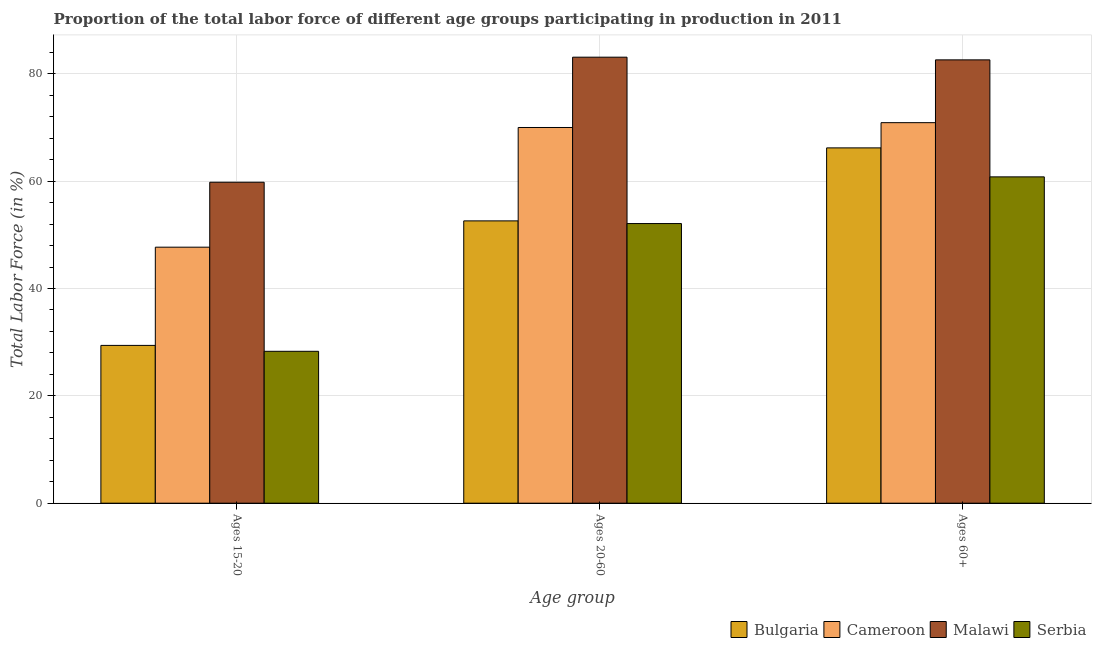How many groups of bars are there?
Give a very brief answer. 3. Are the number of bars on each tick of the X-axis equal?
Give a very brief answer. Yes. How many bars are there on the 2nd tick from the left?
Give a very brief answer. 4. What is the label of the 1st group of bars from the left?
Keep it short and to the point. Ages 15-20. What is the percentage of labor force within the age group 20-60 in Cameroon?
Offer a terse response. 70. Across all countries, what is the maximum percentage of labor force within the age group 20-60?
Your answer should be very brief. 83.1. Across all countries, what is the minimum percentage of labor force above age 60?
Offer a terse response. 60.8. In which country was the percentage of labor force within the age group 20-60 maximum?
Make the answer very short. Malawi. In which country was the percentage of labor force within the age group 15-20 minimum?
Ensure brevity in your answer.  Serbia. What is the total percentage of labor force within the age group 20-60 in the graph?
Offer a terse response. 257.8. What is the difference between the percentage of labor force within the age group 20-60 in Serbia and that in Cameroon?
Your response must be concise. -17.9. What is the difference between the percentage of labor force within the age group 20-60 in Serbia and the percentage of labor force above age 60 in Bulgaria?
Offer a very short reply. -14.1. What is the average percentage of labor force above age 60 per country?
Your response must be concise. 70.12. What is the difference between the percentage of labor force within the age group 15-20 and percentage of labor force within the age group 20-60 in Malawi?
Your response must be concise. -23.3. In how many countries, is the percentage of labor force within the age group 20-60 greater than 16 %?
Your answer should be very brief. 4. What is the ratio of the percentage of labor force within the age group 20-60 in Bulgaria to that in Malawi?
Ensure brevity in your answer.  0.63. Is the percentage of labor force within the age group 15-20 in Malawi less than that in Cameroon?
Offer a very short reply. No. Is the difference between the percentage of labor force within the age group 20-60 in Malawi and Bulgaria greater than the difference between the percentage of labor force within the age group 15-20 in Malawi and Bulgaria?
Your answer should be compact. Yes. What is the difference between the highest and the second highest percentage of labor force within the age group 15-20?
Your answer should be compact. 12.1. What is the difference between the highest and the lowest percentage of labor force above age 60?
Ensure brevity in your answer.  21.8. What does the 3rd bar from the left in Ages 60+ represents?
Your answer should be very brief. Malawi. What does the 2nd bar from the right in Ages 60+ represents?
Offer a very short reply. Malawi. Is it the case that in every country, the sum of the percentage of labor force within the age group 15-20 and percentage of labor force within the age group 20-60 is greater than the percentage of labor force above age 60?
Keep it short and to the point. Yes. What is the difference between two consecutive major ticks on the Y-axis?
Ensure brevity in your answer.  20. Where does the legend appear in the graph?
Offer a terse response. Bottom right. How many legend labels are there?
Your answer should be compact. 4. What is the title of the graph?
Provide a short and direct response. Proportion of the total labor force of different age groups participating in production in 2011. What is the label or title of the X-axis?
Your response must be concise. Age group. What is the Total Labor Force (in %) of Bulgaria in Ages 15-20?
Provide a succinct answer. 29.4. What is the Total Labor Force (in %) of Cameroon in Ages 15-20?
Keep it short and to the point. 47.7. What is the Total Labor Force (in %) in Malawi in Ages 15-20?
Give a very brief answer. 59.8. What is the Total Labor Force (in %) in Serbia in Ages 15-20?
Make the answer very short. 28.3. What is the Total Labor Force (in %) of Bulgaria in Ages 20-60?
Offer a very short reply. 52.6. What is the Total Labor Force (in %) of Malawi in Ages 20-60?
Your answer should be compact. 83.1. What is the Total Labor Force (in %) in Serbia in Ages 20-60?
Your answer should be compact. 52.1. What is the Total Labor Force (in %) of Bulgaria in Ages 60+?
Your response must be concise. 66.2. What is the Total Labor Force (in %) in Cameroon in Ages 60+?
Provide a short and direct response. 70.9. What is the Total Labor Force (in %) of Malawi in Ages 60+?
Ensure brevity in your answer.  82.6. What is the Total Labor Force (in %) in Serbia in Ages 60+?
Provide a short and direct response. 60.8. Across all Age group, what is the maximum Total Labor Force (in %) in Bulgaria?
Keep it short and to the point. 66.2. Across all Age group, what is the maximum Total Labor Force (in %) of Cameroon?
Your answer should be compact. 70.9. Across all Age group, what is the maximum Total Labor Force (in %) of Malawi?
Your answer should be very brief. 83.1. Across all Age group, what is the maximum Total Labor Force (in %) of Serbia?
Offer a terse response. 60.8. Across all Age group, what is the minimum Total Labor Force (in %) in Bulgaria?
Provide a short and direct response. 29.4. Across all Age group, what is the minimum Total Labor Force (in %) in Cameroon?
Ensure brevity in your answer.  47.7. Across all Age group, what is the minimum Total Labor Force (in %) of Malawi?
Offer a very short reply. 59.8. Across all Age group, what is the minimum Total Labor Force (in %) of Serbia?
Your response must be concise. 28.3. What is the total Total Labor Force (in %) in Bulgaria in the graph?
Offer a terse response. 148.2. What is the total Total Labor Force (in %) in Cameroon in the graph?
Ensure brevity in your answer.  188.6. What is the total Total Labor Force (in %) of Malawi in the graph?
Offer a very short reply. 225.5. What is the total Total Labor Force (in %) in Serbia in the graph?
Your answer should be compact. 141.2. What is the difference between the Total Labor Force (in %) in Bulgaria in Ages 15-20 and that in Ages 20-60?
Ensure brevity in your answer.  -23.2. What is the difference between the Total Labor Force (in %) in Cameroon in Ages 15-20 and that in Ages 20-60?
Ensure brevity in your answer.  -22.3. What is the difference between the Total Labor Force (in %) of Malawi in Ages 15-20 and that in Ages 20-60?
Your answer should be compact. -23.3. What is the difference between the Total Labor Force (in %) of Serbia in Ages 15-20 and that in Ages 20-60?
Make the answer very short. -23.8. What is the difference between the Total Labor Force (in %) of Bulgaria in Ages 15-20 and that in Ages 60+?
Provide a short and direct response. -36.8. What is the difference between the Total Labor Force (in %) of Cameroon in Ages 15-20 and that in Ages 60+?
Your answer should be very brief. -23.2. What is the difference between the Total Labor Force (in %) of Malawi in Ages 15-20 and that in Ages 60+?
Give a very brief answer. -22.8. What is the difference between the Total Labor Force (in %) of Serbia in Ages 15-20 and that in Ages 60+?
Ensure brevity in your answer.  -32.5. What is the difference between the Total Labor Force (in %) in Cameroon in Ages 20-60 and that in Ages 60+?
Offer a very short reply. -0.9. What is the difference between the Total Labor Force (in %) in Malawi in Ages 20-60 and that in Ages 60+?
Your answer should be very brief. 0.5. What is the difference between the Total Labor Force (in %) of Bulgaria in Ages 15-20 and the Total Labor Force (in %) of Cameroon in Ages 20-60?
Your answer should be compact. -40.6. What is the difference between the Total Labor Force (in %) of Bulgaria in Ages 15-20 and the Total Labor Force (in %) of Malawi in Ages 20-60?
Your answer should be very brief. -53.7. What is the difference between the Total Labor Force (in %) in Bulgaria in Ages 15-20 and the Total Labor Force (in %) in Serbia in Ages 20-60?
Give a very brief answer. -22.7. What is the difference between the Total Labor Force (in %) of Cameroon in Ages 15-20 and the Total Labor Force (in %) of Malawi in Ages 20-60?
Provide a succinct answer. -35.4. What is the difference between the Total Labor Force (in %) in Malawi in Ages 15-20 and the Total Labor Force (in %) in Serbia in Ages 20-60?
Ensure brevity in your answer.  7.7. What is the difference between the Total Labor Force (in %) in Bulgaria in Ages 15-20 and the Total Labor Force (in %) in Cameroon in Ages 60+?
Give a very brief answer. -41.5. What is the difference between the Total Labor Force (in %) of Bulgaria in Ages 15-20 and the Total Labor Force (in %) of Malawi in Ages 60+?
Offer a very short reply. -53.2. What is the difference between the Total Labor Force (in %) in Bulgaria in Ages 15-20 and the Total Labor Force (in %) in Serbia in Ages 60+?
Your answer should be compact. -31.4. What is the difference between the Total Labor Force (in %) in Cameroon in Ages 15-20 and the Total Labor Force (in %) in Malawi in Ages 60+?
Provide a succinct answer. -34.9. What is the difference between the Total Labor Force (in %) in Bulgaria in Ages 20-60 and the Total Labor Force (in %) in Cameroon in Ages 60+?
Provide a succinct answer. -18.3. What is the difference between the Total Labor Force (in %) in Bulgaria in Ages 20-60 and the Total Labor Force (in %) in Malawi in Ages 60+?
Your answer should be very brief. -30. What is the difference between the Total Labor Force (in %) in Cameroon in Ages 20-60 and the Total Labor Force (in %) in Serbia in Ages 60+?
Your answer should be very brief. 9.2. What is the difference between the Total Labor Force (in %) of Malawi in Ages 20-60 and the Total Labor Force (in %) of Serbia in Ages 60+?
Make the answer very short. 22.3. What is the average Total Labor Force (in %) in Bulgaria per Age group?
Provide a succinct answer. 49.4. What is the average Total Labor Force (in %) of Cameroon per Age group?
Make the answer very short. 62.87. What is the average Total Labor Force (in %) of Malawi per Age group?
Make the answer very short. 75.17. What is the average Total Labor Force (in %) in Serbia per Age group?
Ensure brevity in your answer.  47.07. What is the difference between the Total Labor Force (in %) in Bulgaria and Total Labor Force (in %) in Cameroon in Ages 15-20?
Your response must be concise. -18.3. What is the difference between the Total Labor Force (in %) of Bulgaria and Total Labor Force (in %) of Malawi in Ages 15-20?
Make the answer very short. -30.4. What is the difference between the Total Labor Force (in %) in Bulgaria and Total Labor Force (in %) in Serbia in Ages 15-20?
Provide a short and direct response. 1.1. What is the difference between the Total Labor Force (in %) in Cameroon and Total Labor Force (in %) in Malawi in Ages 15-20?
Give a very brief answer. -12.1. What is the difference between the Total Labor Force (in %) in Malawi and Total Labor Force (in %) in Serbia in Ages 15-20?
Your response must be concise. 31.5. What is the difference between the Total Labor Force (in %) in Bulgaria and Total Labor Force (in %) in Cameroon in Ages 20-60?
Your response must be concise. -17.4. What is the difference between the Total Labor Force (in %) in Bulgaria and Total Labor Force (in %) in Malawi in Ages 20-60?
Make the answer very short. -30.5. What is the difference between the Total Labor Force (in %) in Cameroon and Total Labor Force (in %) in Serbia in Ages 20-60?
Offer a very short reply. 17.9. What is the difference between the Total Labor Force (in %) in Malawi and Total Labor Force (in %) in Serbia in Ages 20-60?
Your answer should be compact. 31. What is the difference between the Total Labor Force (in %) in Bulgaria and Total Labor Force (in %) in Malawi in Ages 60+?
Make the answer very short. -16.4. What is the difference between the Total Labor Force (in %) of Cameroon and Total Labor Force (in %) of Malawi in Ages 60+?
Your answer should be compact. -11.7. What is the difference between the Total Labor Force (in %) in Cameroon and Total Labor Force (in %) in Serbia in Ages 60+?
Provide a succinct answer. 10.1. What is the difference between the Total Labor Force (in %) in Malawi and Total Labor Force (in %) in Serbia in Ages 60+?
Give a very brief answer. 21.8. What is the ratio of the Total Labor Force (in %) in Bulgaria in Ages 15-20 to that in Ages 20-60?
Keep it short and to the point. 0.56. What is the ratio of the Total Labor Force (in %) of Cameroon in Ages 15-20 to that in Ages 20-60?
Your answer should be very brief. 0.68. What is the ratio of the Total Labor Force (in %) of Malawi in Ages 15-20 to that in Ages 20-60?
Make the answer very short. 0.72. What is the ratio of the Total Labor Force (in %) in Serbia in Ages 15-20 to that in Ages 20-60?
Give a very brief answer. 0.54. What is the ratio of the Total Labor Force (in %) in Bulgaria in Ages 15-20 to that in Ages 60+?
Your answer should be very brief. 0.44. What is the ratio of the Total Labor Force (in %) of Cameroon in Ages 15-20 to that in Ages 60+?
Offer a very short reply. 0.67. What is the ratio of the Total Labor Force (in %) of Malawi in Ages 15-20 to that in Ages 60+?
Give a very brief answer. 0.72. What is the ratio of the Total Labor Force (in %) of Serbia in Ages 15-20 to that in Ages 60+?
Offer a terse response. 0.47. What is the ratio of the Total Labor Force (in %) of Bulgaria in Ages 20-60 to that in Ages 60+?
Keep it short and to the point. 0.79. What is the ratio of the Total Labor Force (in %) in Cameroon in Ages 20-60 to that in Ages 60+?
Your answer should be compact. 0.99. What is the ratio of the Total Labor Force (in %) in Serbia in Ages 20-60 to that in Ages 60+?
Your answer should be very brief. 0.86. What is the difference between the highest and the second highest Total Labor Force (in %) in Bulgaria?
Provide a succinct answer. 13.6. What is the difference between the highest and the second highest Total Labor Force (in %) in Cameroon?
Give a very brief answer. 0.9. What is the difference between the highest and the lowest Total Labor Force (in %) of Bulgaria?
Give a very brief answer. 36.8. What is the difference between the highest and the lowest Total Labor Force (in %) in Cameroon?
Provide a succinct answer. 23.2. What is the difference between the highest and the lowest Total Labor Force (in %) of Malawi?
Your answer should be compact. 23.3. What is the difference between the highest and the lowest Total Labor Force (in %) in Serbia?
Keep it short and to the point. 32.5. 